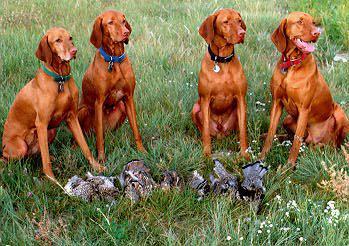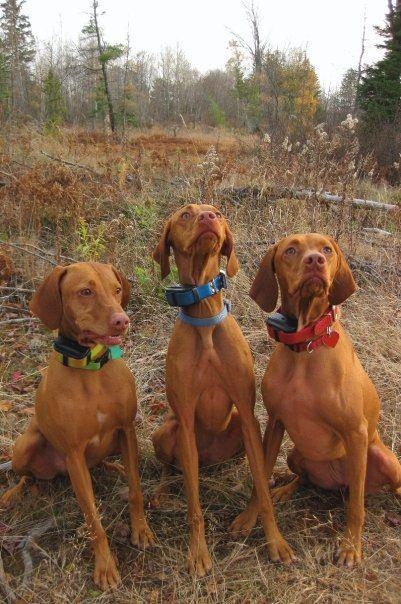The first image is the image on the left, the second image is the image on the right. Considering the images on both sides, is "There is a dog wearing a red collar in each image." valid? Answer yes or no. Yes. The first image is the image on the left, the second image is the image on the right. Analyze the images presented: Is the assertion "There is the same number of dogs in both images." valid? Answer yes or no. No. 